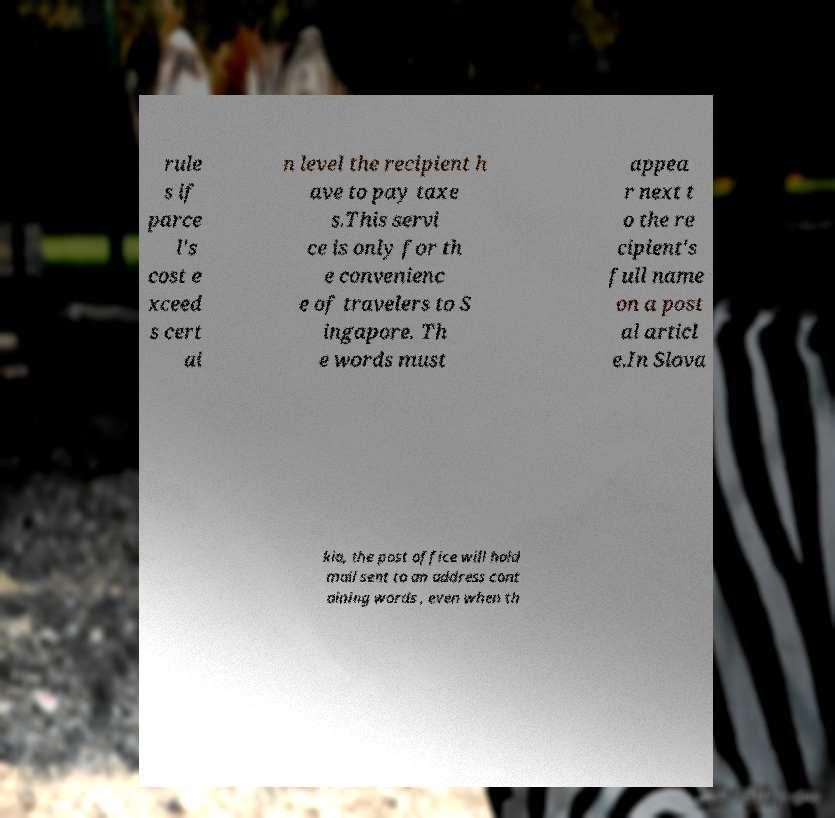I need the written content from this picture converted into text. Can you do that? rule s if parce l's cost e xceed s cert ai n level the recipient h ave to pay taxe s.This servi ce is only for th e convenienc e of travelers to S ingapore. Th e words must appea r next t o the re cipient's full name on a post al articl e.In Slova kia, the post office will hold mail sent to an address cont aining words , even when th 